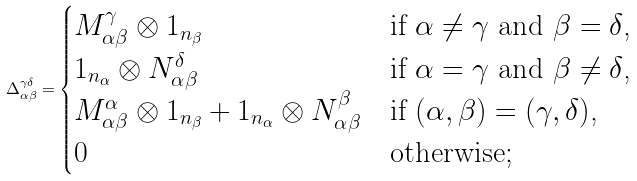<formula> <loc_0><loc_0><loc_500><loc_500>\Delta _ { \alpha \beta } ^ { \gamma \delta } = \begin{cases} M _ { \alpha \beta } ^ { \gamma } \otimes 1 _ { n _ { \beta } } & \text {if $\alpha \neq \gamma$ and $\beta = \delta$,} \\ 1 _ { n _ { \alpha } } \otimes N _ { \alpha \beta } ^ { \delta } & \text {if $\alpha = \gamma$ and $\beta \neq \delta$,} \\ M _ { \alpha \beta } ^ { \alpha } \otimes 1 _ { n _ { \beta } } + 1 _ { n _ { \alpha } } \otimes N _ { \alpha \beta } ^ { \beta } & \text {if $(\alpha,\beta) = (\gamma,\delta)$,} \\ 0 & \text {otherwise;} \\ \end{cases}</formula> 